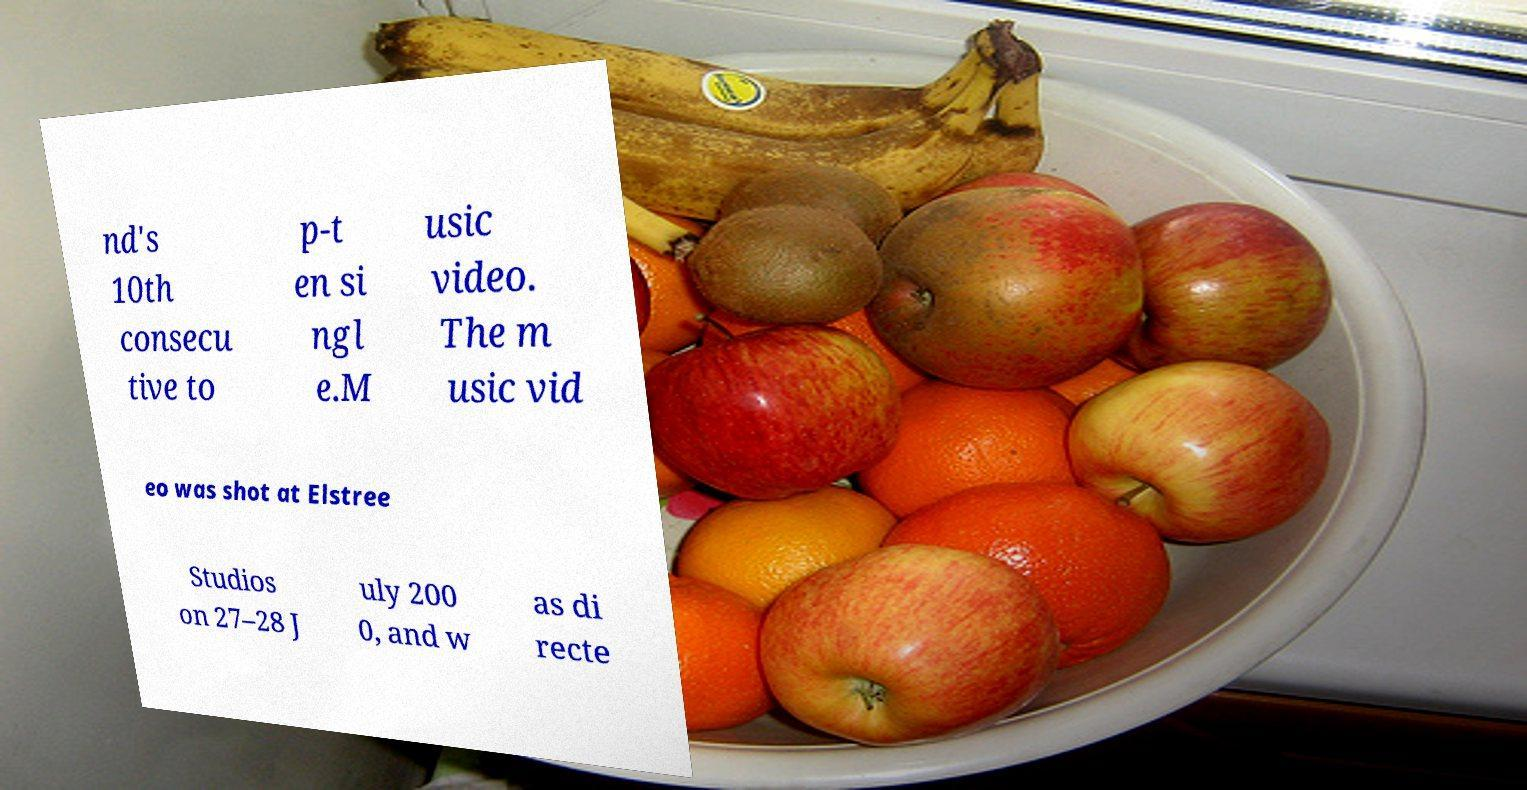For documentation purposes, I need the text within this image transcribed. Could you provide that? nd's 10th consecu tive to p-t en si ngl e.M usic video. The m usic vid eo was shot at Elstree Studios on 27–28 J uly 200 0, and w as di recte 